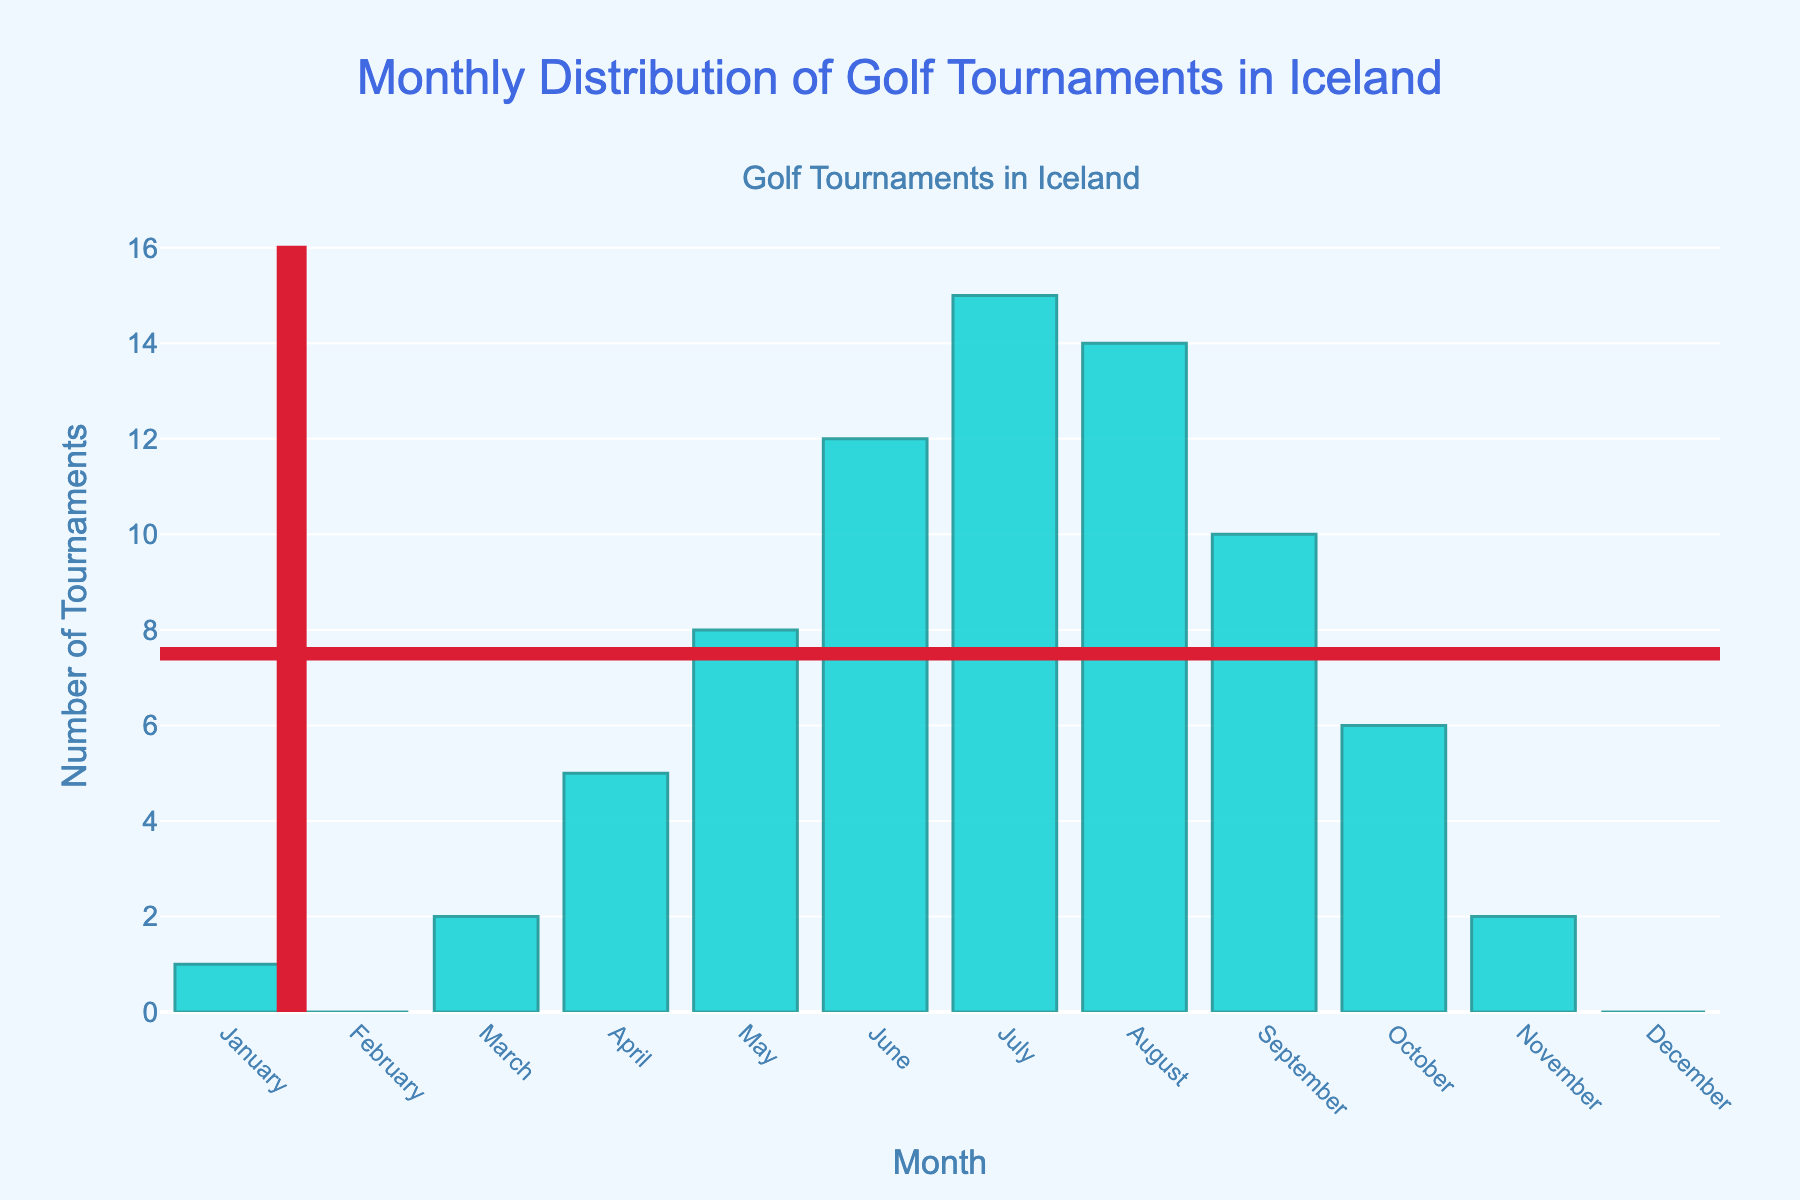Which month has the highest number of golf tournaments? July has the highest bar on the chart with 15 tournaments, making it the month with the highest number of golf tournaments.
Answer: July Which two consecutive months have the highest combined number of tournaments? July and August have 15 and 14 tournaments respectively, so the combined number is 15 + 14 = 29, which is higher than any other consecutive months.
Answer: July and August How many tournaments are held in the first six months of the year? Sum the number of tournaments from January to June: 1 + 0 + 2 + 5 + 8 + 12 = 28. Therefore, 28 tournaments are held in the first six months.
Answer: 28 Are there any months with zero tournaments? The chart shows that February and December each have a bar height of zero, indicating no tournaments in these months.
Answer: Yes, February and December Which month has more tournaments, April or October? April has 5 tournaments and October has 6. Therefore, October has one more tournament than April.
Answer: October In which month does the number of tournaments first reach double digits? The chart shows that the number of tournaments reaches 10 for the first time in June.
Answer: June What is the average number of tournaments per month? The total number of tournaments across all months is 75. The average is calculated as 75 tournaments divided by 12 months, which equals 6.25 tournaments per month.
Answer: 6.25 How does the number of tournaments in September compare to that in May? September has 10 tournaments, while May has 8. Therefore, September has 2 more tournaments than May.
Answer: September has 2 more What's the total number of tournaments held in the last quarter of the year? Sum the number of tournaments from October to December: 6 (October) + 2 (November) + 0 (December) = 8. Therefore, 8 tournaments are held in the last quarter.
Answer: 8 Which month experiences the biggest increase in number of tournaments compared to the previous month? June increases from May's 8 tournaments to 12, a difference of 4. No other months have a greater increase.
Answer: June 